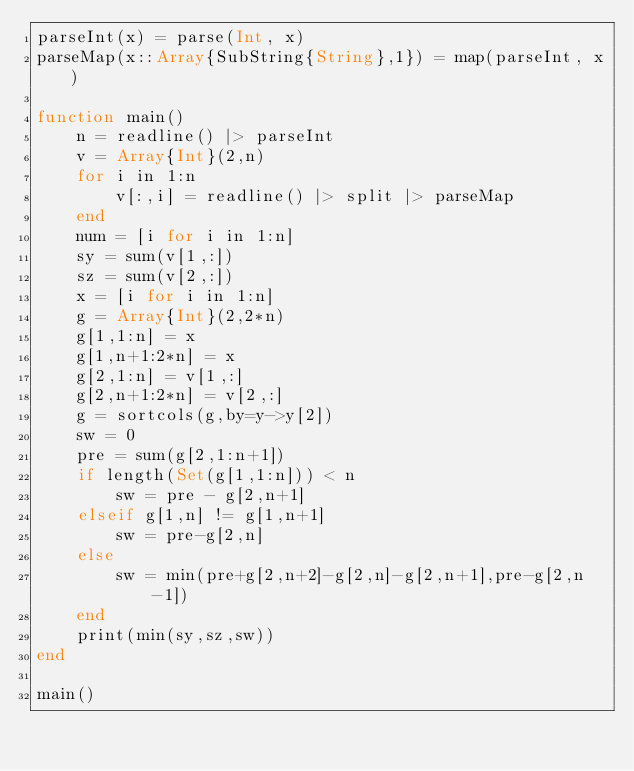<code> <loc_0><loc_0><loc_500><loc_500><_Julia_>parseInt(x) = parse(Int, x)
parseMap(x::Array{SubString{String},1}) = map(parseInt, x)

function main()
	n = readline() |> parseInt
	v = Array{Int}(2,n)
	for i in 1:n
		v[:,i] = readline() |> split |> parseMap
	end
	num = [i for i in 1:n]
	sy = sum(v[1,:])
	sz = sum(v[2,:])
	x = [i for i in 1:n]
	g = Array{Int}(2,2*n)
	g[1,1:n] = x
	g[1,n+1:2*n] = x
	g[2,1:n] = v[1,:]
	g[2,n+1:2*n] = v[2,:]
	g = sortcols(g,by=y->y[2])
	sw = 0
	pre = sum(g[2,1:n+1])
	if length(Set(g[1,1:n])) < n
		sw = pre - g[2,n+1]
	elseif g[1,n] != g[1,n+1]
		sw = pre-g[2,n]
	else
		sw = min(pre+g[2,n+2]-g[2,n]-g[2,n+1],pre-g[2,n-1])
	end
	print(min(sy,sz,sw))
end

main()</code> 